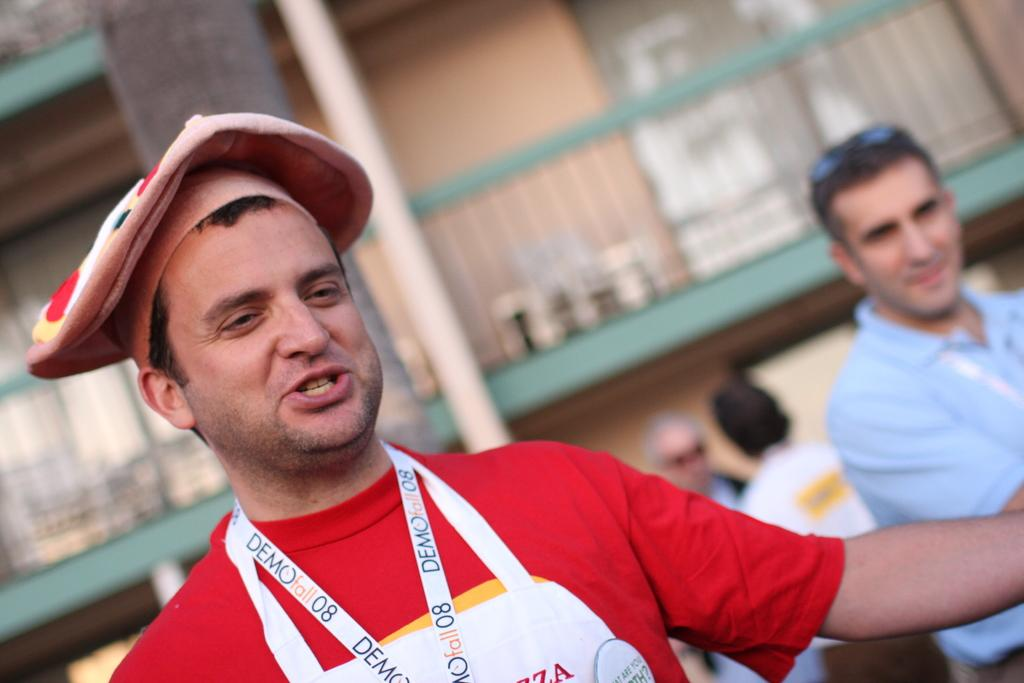<image>
Present a compact description of the photo's key features. Aman wearing a apron with demo written on it is wearing a funny looking hat. 